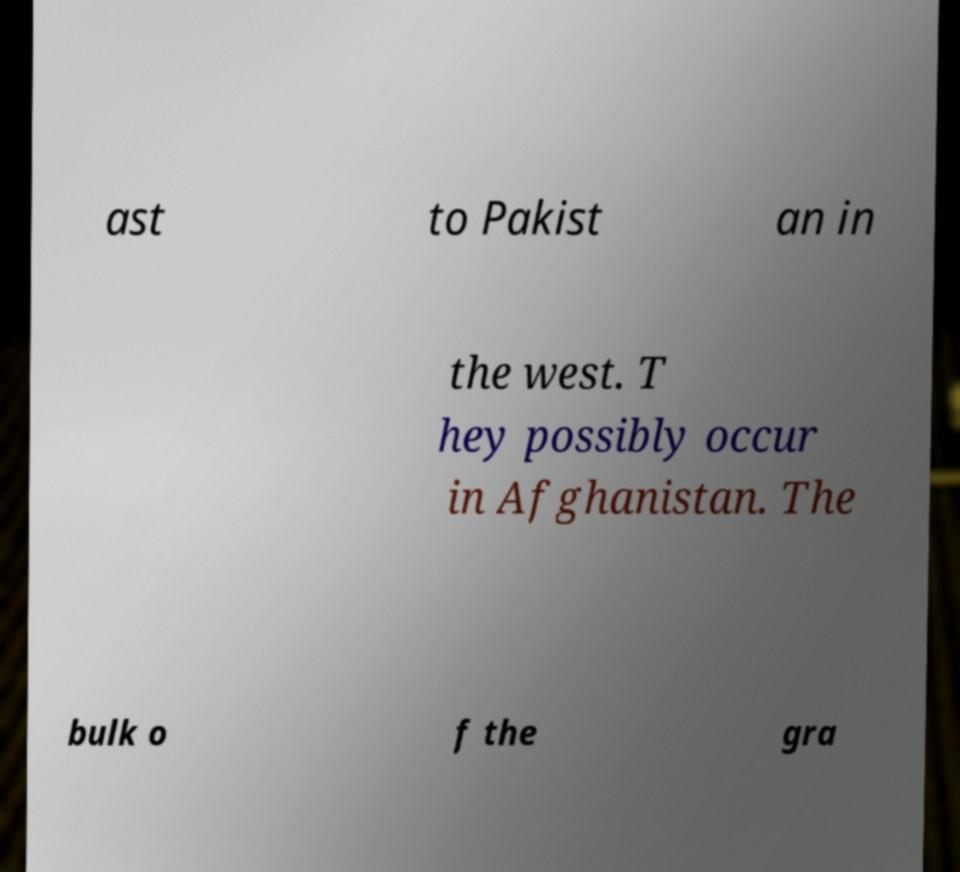Could you assist in decoding the text presented in this image and type it out clearly? ast to Pakist an in the west. T hey possibly occur in Afghanistan. The bulk o f the gra 